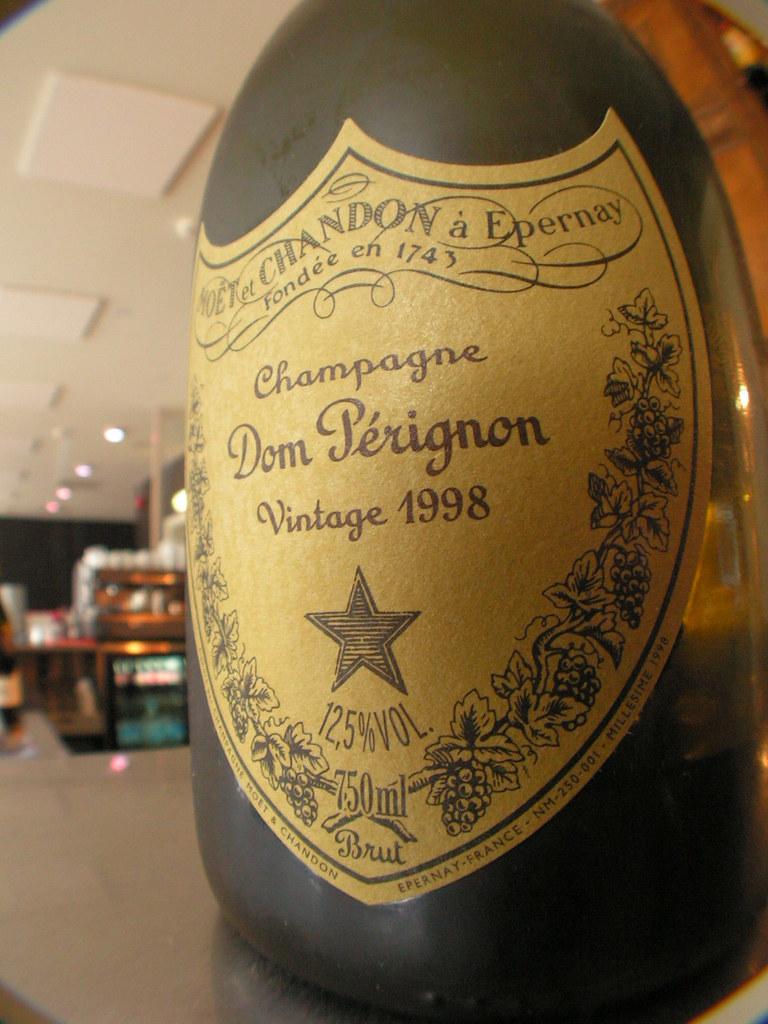What type of champagne is in the bottle?
Your answer should be compact. Dom perignon. What year was the wine made?
Your response must be concise. 1998. 